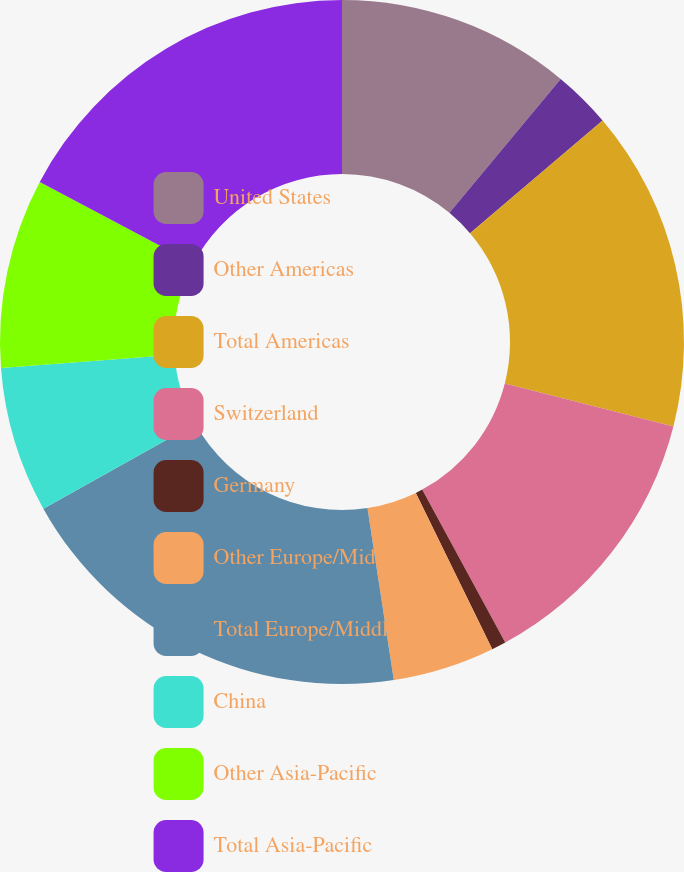<chart> <loc_0><loc_0><loc_500><loc_500><pie_chart><fcel>United States<fcel>Other Americas<fcel>Total Americas<fcel>Switzerland<fcel>Germany<fcel>Other Europe/Middle<fcel>Total Europe/Middle<fcel>China<fcel>Other Asia-Pacific<fcel>Total Asia-Pacific<nl><fcel>11.04%<fcel>2.75%<fcel>15.18%<fcel>13.11%<fcel>0.68%<fcel>4.82%<fcel>19.32%<fcel>6.89%<fcel>8.96%<fcel>17.25%<nl></chart> 